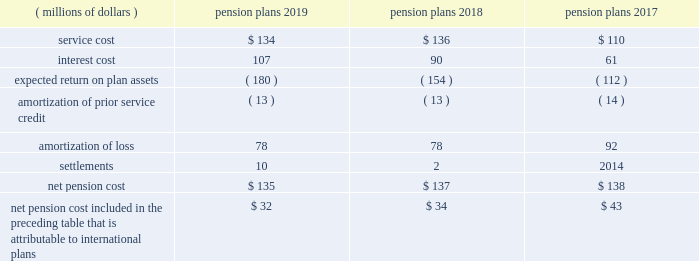Note 9 2014 benefit plans the company has defined benefit pension plans covering certain employees in the united states and certain international locations .
Postretirement healthcare and life insurance benefits provided to qualifying domestic retirees as well as other postretirement benefit plans in international countries are not material .
The measurement date used for the company 2019s employee benefit plans is september 30 .
Effective january 1 , 2018 , the legacy u.s .
Pension plan was frozen to limit the participation of employees who are hired or re-hired by the company , or who transfer employment to the company , on or after january 1 , net pension cost for the years ended september 30 included the following components: .
Net pension cost included in the preceding table that is attributable to international plans $ 32 $ 34 $ 43 the amounts provided above for amortization of prior service credit and amortization of loss represent the reclassifications of prior service credits and net actuarial losses that were recognized in accumulated other comprehensive income ( loss ) in prior periods .
The settlement losses recorded in 2019 and 2018 primarily included lump sum benefit payments associated with the company 2019s u.s .
Supplemental pension plan .
The company recognizes pension settlements when payments from the supplemental plan exceed the sum of service and interest cost components of net periodic pension cost associated with this plan for the fiscal year .
As further discussed in note 2 , upon adopting an accounting standard update on october 1 , 2018 , all components of the company 2019s net periodic pension and postretirement benefit costs , aside from service cost , are recorded to other income ( expense ) , net on its consolidated statements of income , for all periods presented .
Notes to consolidated financial statements 2014 ( continued ) becton , dickinson and company .
In 2017 what was the ratio of the pension service cost to the interest cost? 
Computations: (110 / 61)
Answer: 1.80328. 